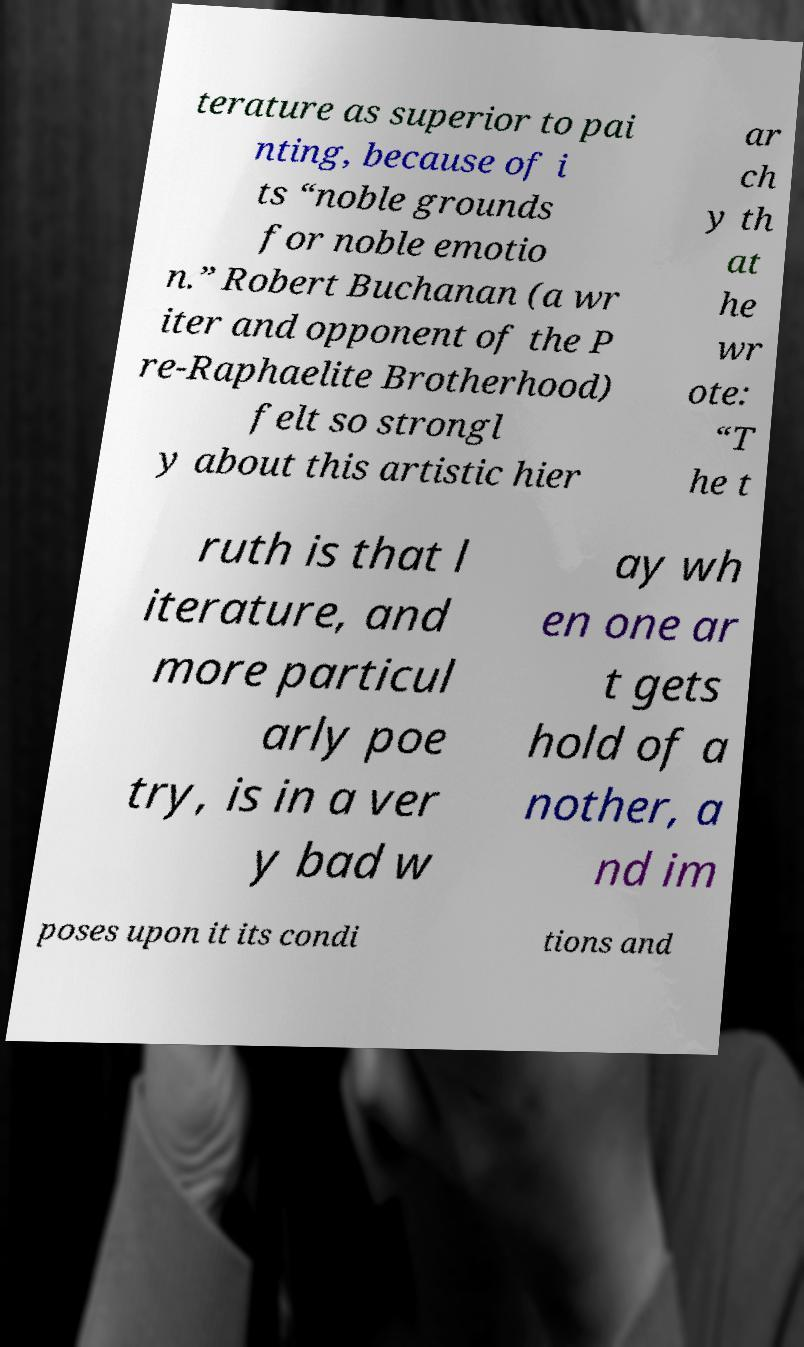Please identify and transcribe the text found in this image. terature as superior to pai nting, because of i ts “noble grounds for noble emotio n.” Robert Buchanan (a wr iter and opponent of the P re-Raphaelite Brotherhood) felt so strongl y about this artistic hier ar ch y th at he wr ote: “T he t ruth is that l iterature, and more particul arly poe try, is in a ver y bad w ay wh en one ar t gets hold of a nother, a nd im poses upon it its condi tions and 